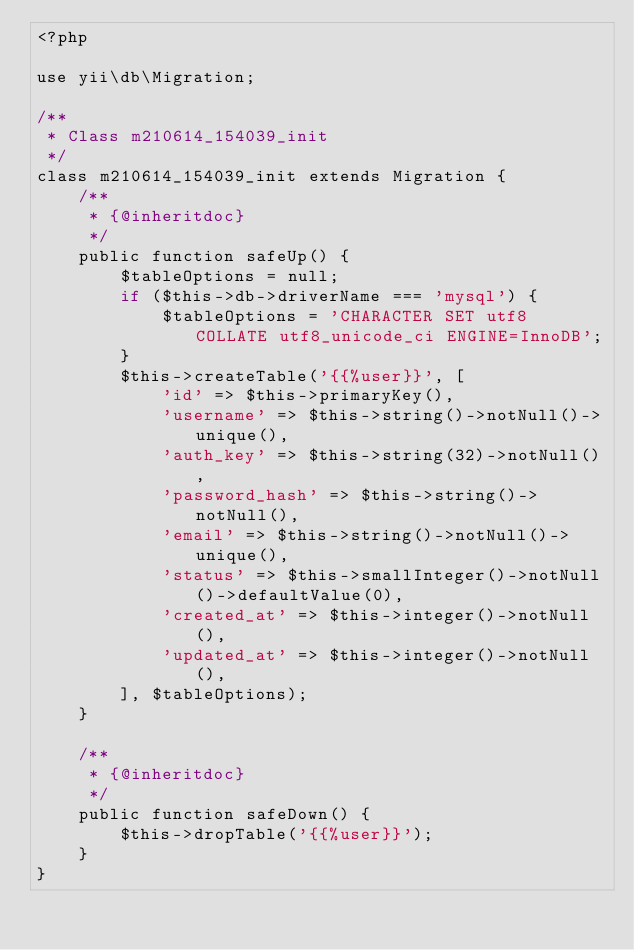Convert code to text. <code><loc_0><loc_0><loc_500><loc_500><_PHP_><?php

use yii\db\Migration;

/**
 * Class m210614_154039_init
 */
class m210614_154039_init extends Migration {
	/**
	 * {@inheritdoc}
	 */
	public function safeUp() {
		$tableOptions = null;
		if ($this->db->driverName === 'mysql') {
			$tableOptions = 'CHARACTER SET utf8 COLLATE utf8_unicode_ci ENGINE=InnoDB';
		}
		$this->createTable('{{%user}}', [
			'id' => $this->primaryKey(),
			'username' => $this->string()->notNull()->unique(),
			'auth_key' => $this->string(32)->notNull(),
			'password_hash' => $this->string()->notNull(),
			'email' => $this->string()->notNull()->unique(),
			'status' => $this->smallInteger()->notNull()->defaultValue(0),
			'created_at' => $this->integer()->notNull(),
			'updated_at' => $this->integer()->notNull(),
		], $tableOptions);
	}

	/**
	 * {@inheritdoc}
	 */
	public function safeDown() {
		$this->dropTable('{{%user}}');
	}
}
</code> 